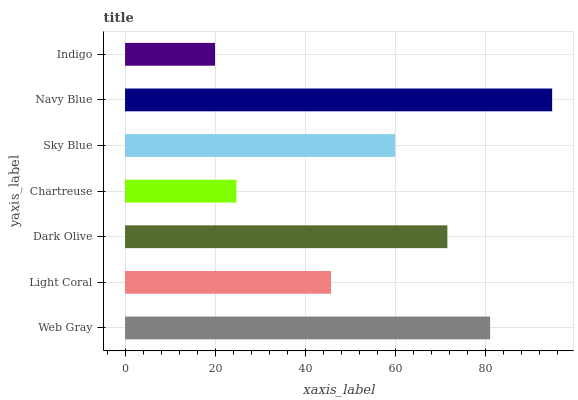Is Indigo the minimum?
Answer yes or no. Yes. Is Navy Blue the maximum?
Answer yes or no. Yes. Is Light Coral the minimum?
Answer yes or no. No. Is Light Coral the maximum?
Answer yes or no. No. Is Web Gray greater than Light Coral?
Answer yes or no. Yes. Is Light Coral less than Web Gray?
Answer yes or no. Yes. Is Light Coral greater than Web Gray?
Answer yes or no. No. Is Web Gray less than Light Coral?
Answer yes or no. No. Is Sky Blue the high median?
Answer yes or no. Yes. Is Sky Blue the low median?
Answer yes or no. Yes. Is Light Coral the high median?
Answer yes or no. No. Is Chartreuse the low median?
Answer yes or no. No. 